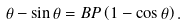<formula> <loc_0><loc_0><loc_500><loc_500>\theta - \sin \theta = B P \left ( 1 - \cos \theta \right ) .</formula> 